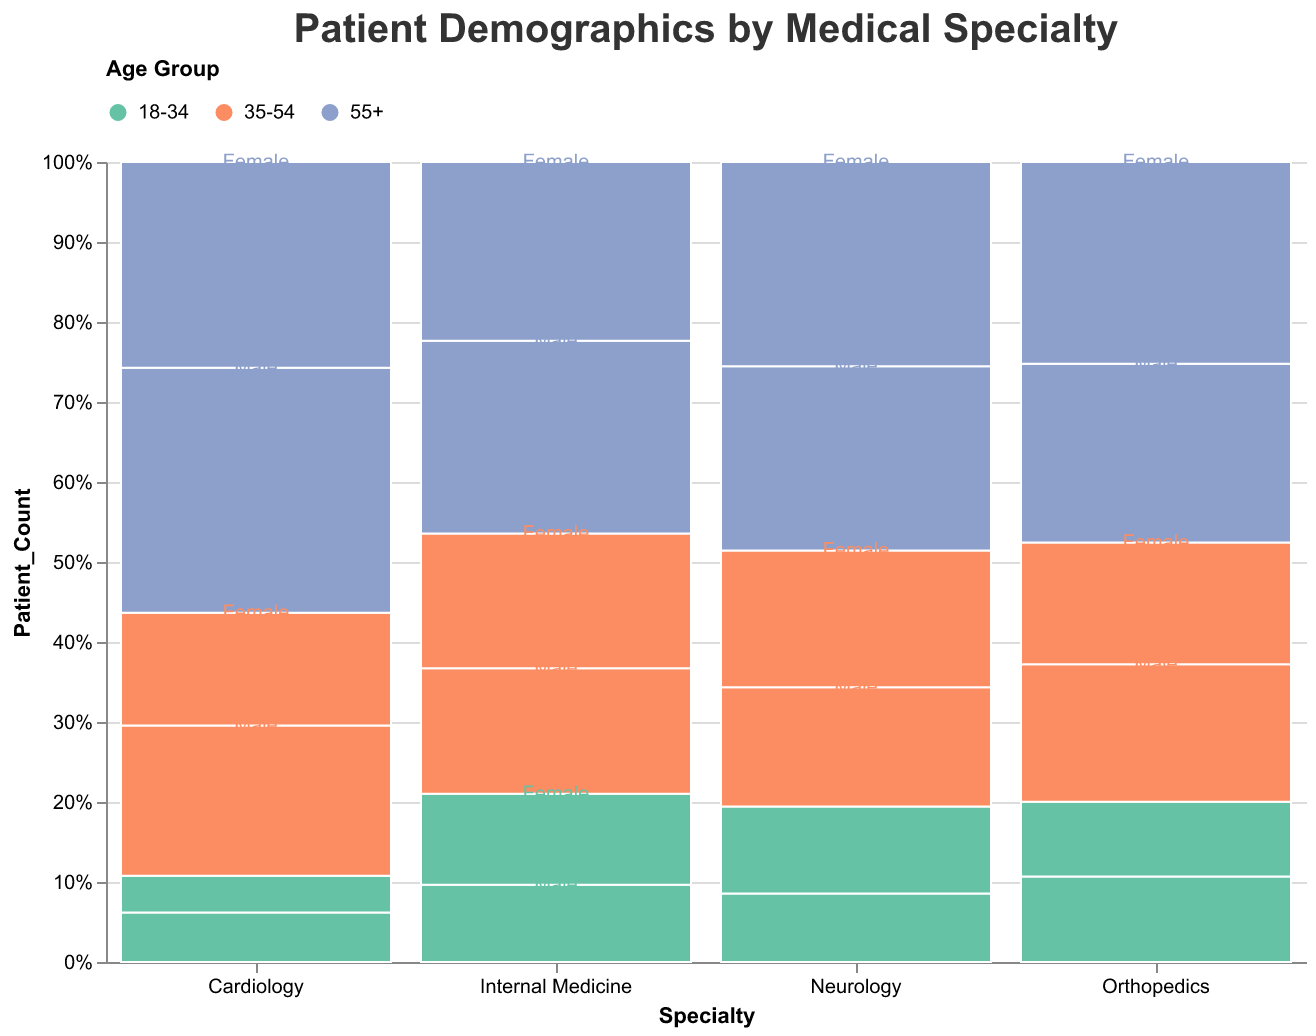What is the title of the figure? The title of the figure is located at the top and it reads "Patient Demographics by Medical Specialty."
Answer: Patient Demographics by Medical Specialty Which specialty has the highest proportion of patients aged 55+? The highest proportion of patients aged 55+ can be seen in the Internal Medicine group, indicated by the largest colored section representing the 55+ age group.
Answer: Internal Medicine What is the gender distribution for the Cardiology specialty in the 18-34 age group? For the Cardiology specialty in the 18-34 age group, you can see the smaller sections labeled with text within the bar. The male patients count is 58 and the female patients count is 43.
Answer: 58 males, 43 females How does the age distribution in Neurology compare to Internal Medicine? In the Neurology group, the proportion of patients is relatively more evenly distributed across age groups compared to Internal Medicine, where the 55+ age group has a significantly larger proportion.
Answer: Neurology has a more even age distribution, while Internal Medicine is skewed towards 55+ Which specialty has the fewest patients overall? By visually comparing the height of the bars, the Cardiology specialty has the shortest bar, indicating it has the fewest patients overall.
Answer: Cardiology 